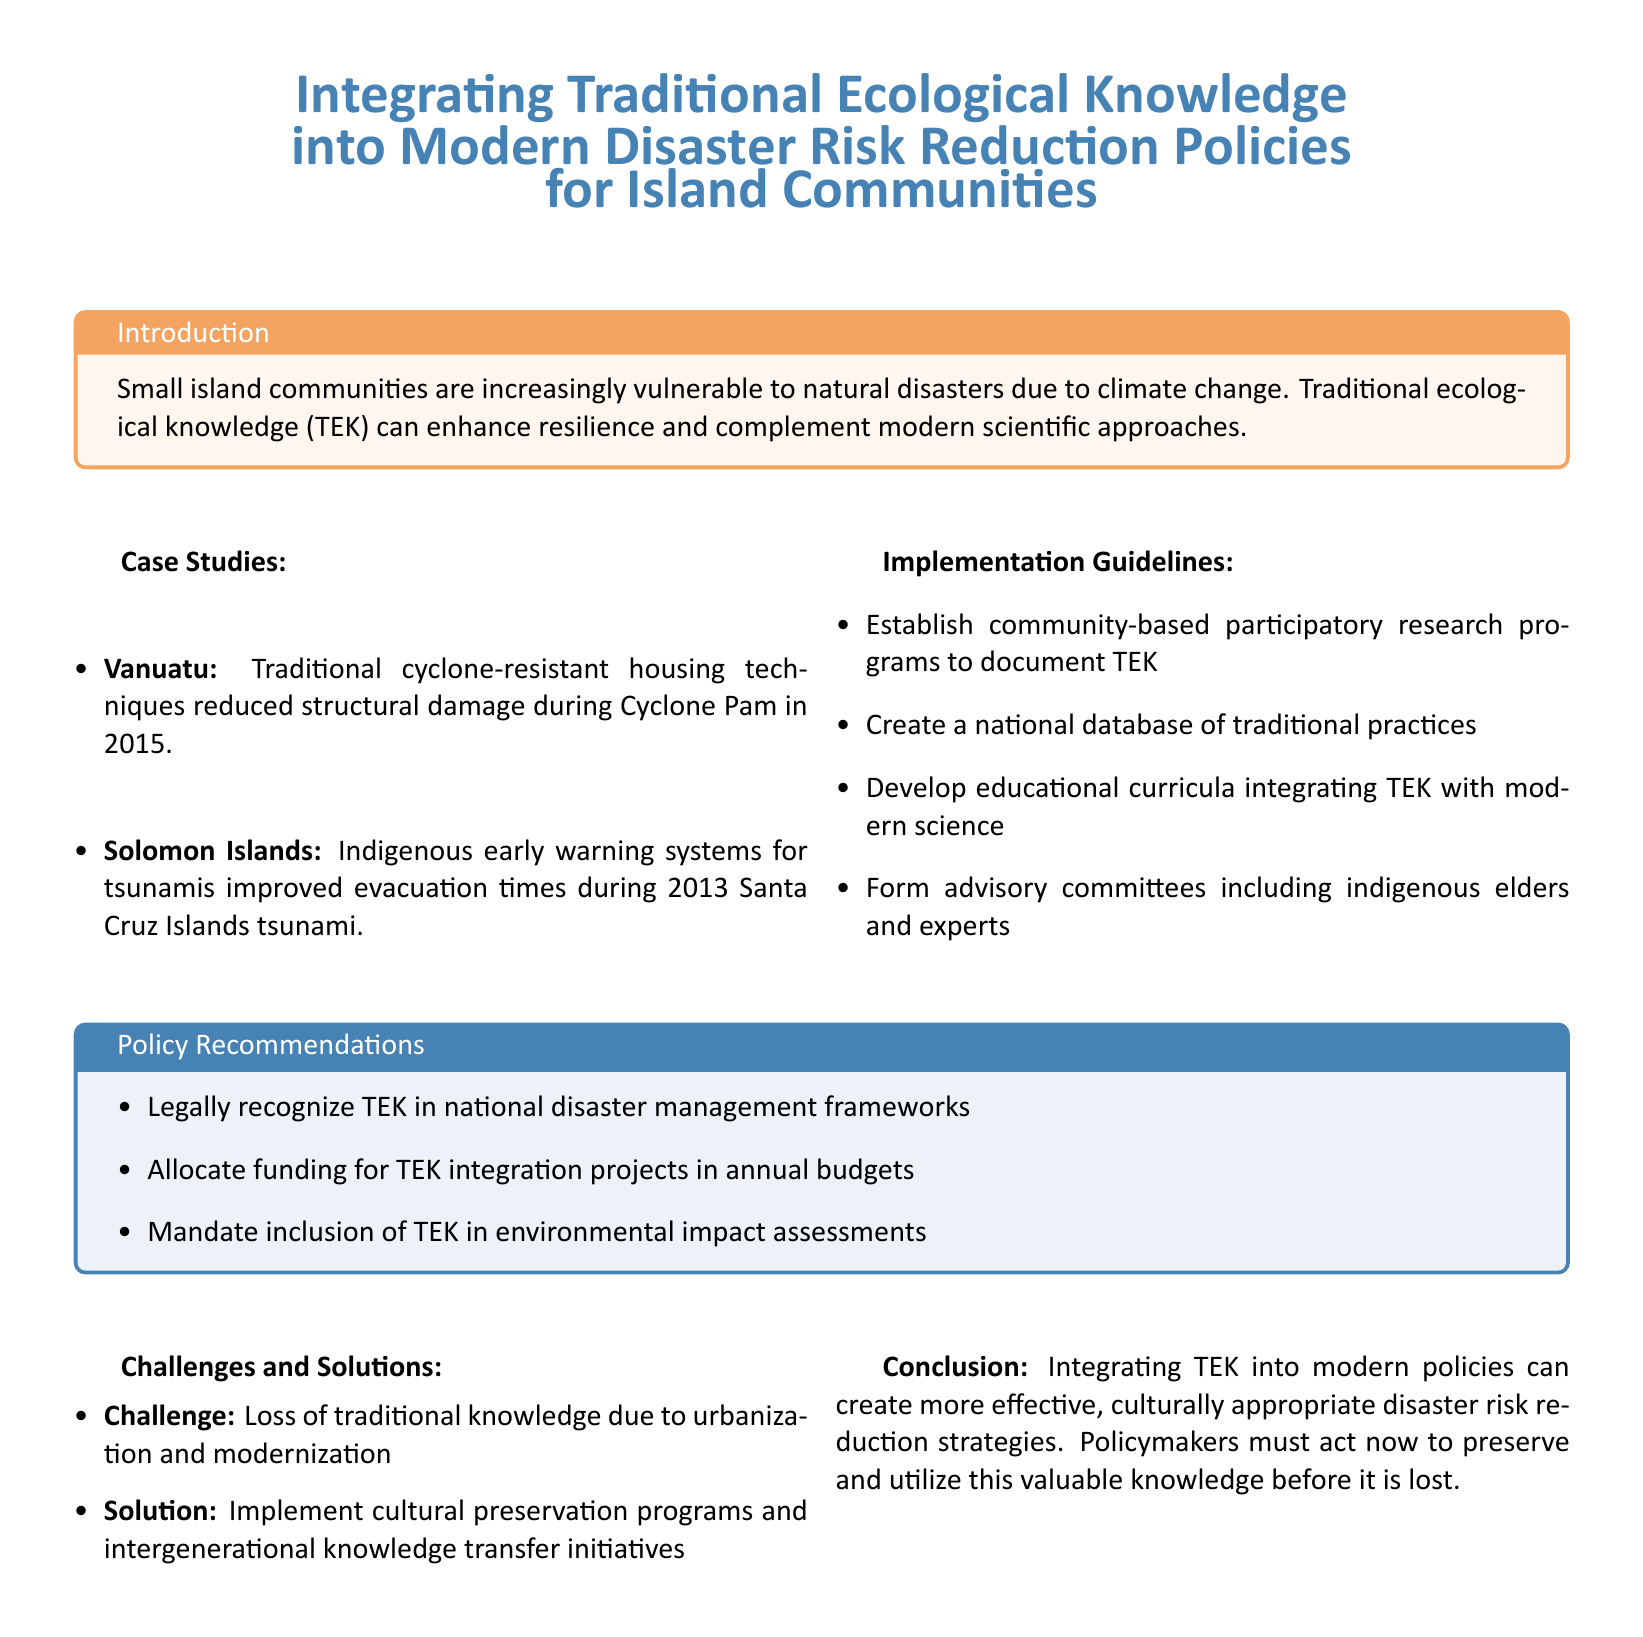What is the title of the document? The title of the document is presented prominently at the top as the main focus.
Answer: Integrating Traditional Ecological Knowledge into Modern Disaster Risk Reduction Policies for Island Communities What year did Cyclone Pam occur? Cyclone Pam is mentioned in the context of a case study, specifically noting its impact on Vanuatu.
Answer: 2015 Which two geographic locations are highlighted in the case studies? The document lists specific examples from island communities to illustrate the integration of TEK.
Answer: Vanuatu and Solomon Islands What is one of the policy recommendations? Policy recommendations section outlines suggested actions for integration of TEK in disaster management.
Answer: Legally recognize TEK in national disaster management frameworks What is a challenge mentioned in the document? The challenges section discusses issues faced by traditional knowledge due to modern influences.
Answer: Loss of traditional knowledge due to urbanization and modernization What is recommended to develop in the educational system? Implementation guidelines suggest blending traditional knowledge with educational curricula.
Answer: Educational curricula integrating TEK with modern science What natural disaster improved evacuation times through indigenous early warning systems? The document references a specific event where TEK contributed to timely responses during a natural disaster.
Answer: Tsunami What type of research programs should be established? Implementation guidelines suggest creating specific participatory research programs to bolster understanding of TEK.
Answer: Community-based participatory research programs 